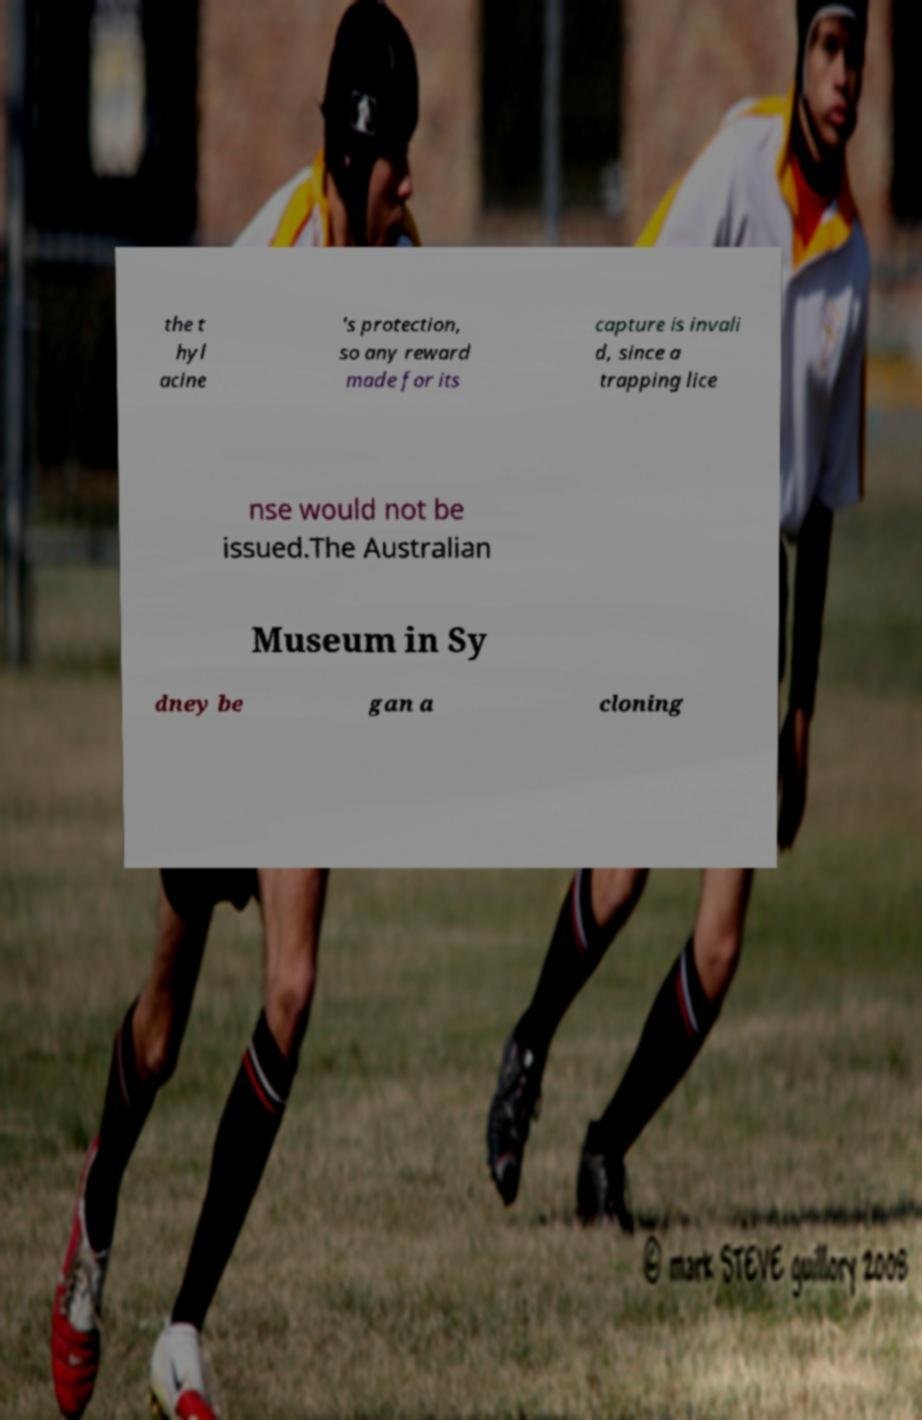Can you read and provide the text displayed in the image?This photo seems to have some interesting text. Can you extract and type it out for me? the t hyl acine 's protection, so any reward made for its capture is invali d, since a trapping lice nse would not be issued.The Australian Museum in Sy dney be gan a cloning 